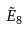Convert formula to latex. <formula><loc_0><loc_0><loc_500><loc_500>\tilde { E } _ { 8 }</formula> 